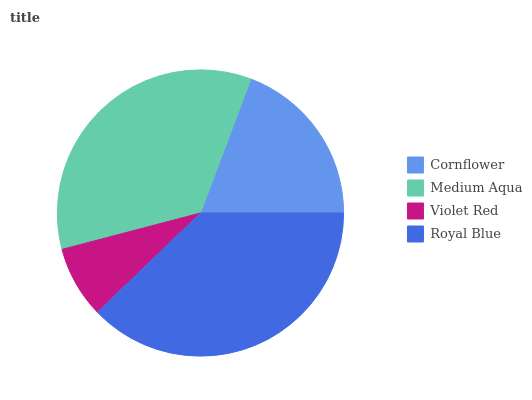Is Violet Red the minimum?
Answer yes or no. Yes. Is Royal Blue the maximum?
Answer yes or no. Yes. Is Medium Aqua the minimum?
Answer yes or no. No. Is Medium Aqua the maximum?
Answer yes or no. No. Is Medium Aqua greater than Cornflower?
Answer yes or no. Yes. Is Cornflower less than Medium Aqua?
Answer yes or no. Yes. Is Cornflower greater than Medium Aqua?
Answer yes or no. No. Is Medium Aqua less than Cornflower?
Answer yes or no. No. Is Medium Aqua the high median?
Answer yes or no. Yes. Is Cornflower the low median?
Answer yes or no. Yes. Is Cornflower the high median?
Answer yes or no. No. Is Royal Blue the low median?
Answer yes or no. No. 